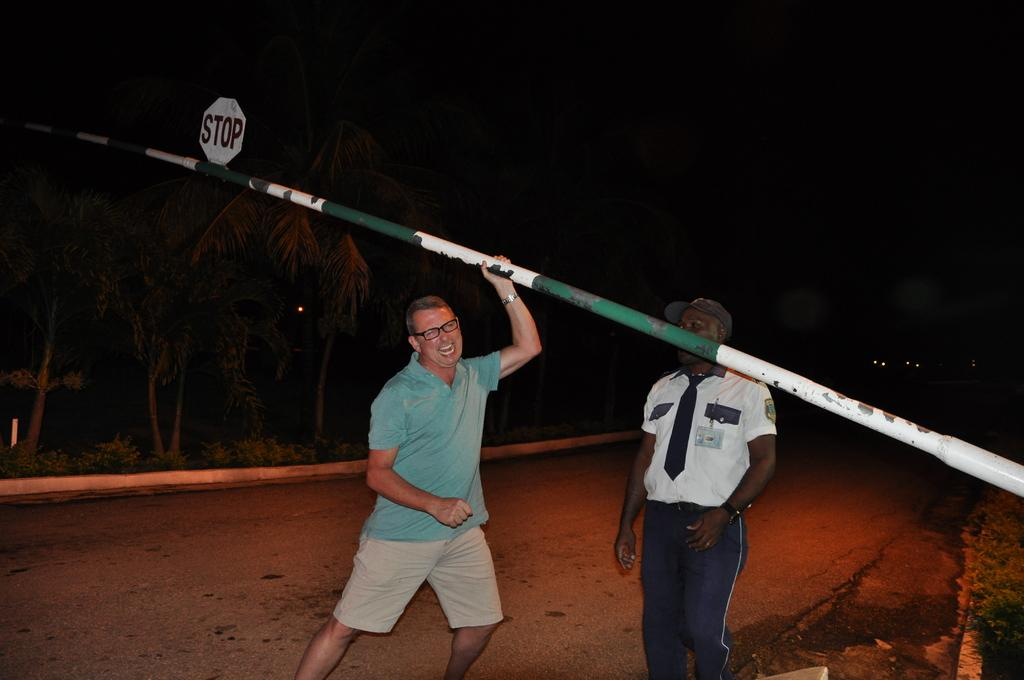How many people are present in the image? There are two persons standing on the road in the image. What can be seen in the image besides the people? There is a pole, a stop board, and trees visible in the image. What is the color of the background in the image? The background of the image is dark. Can you tell me how many beggars are present in the image? There are no beggars present in the image; it only shows two persons standing on the road. What type of competition is taking place in the image? There is no competition present in the image; it only shows two persons standing on the road, a pole, a stop board, and trees. 